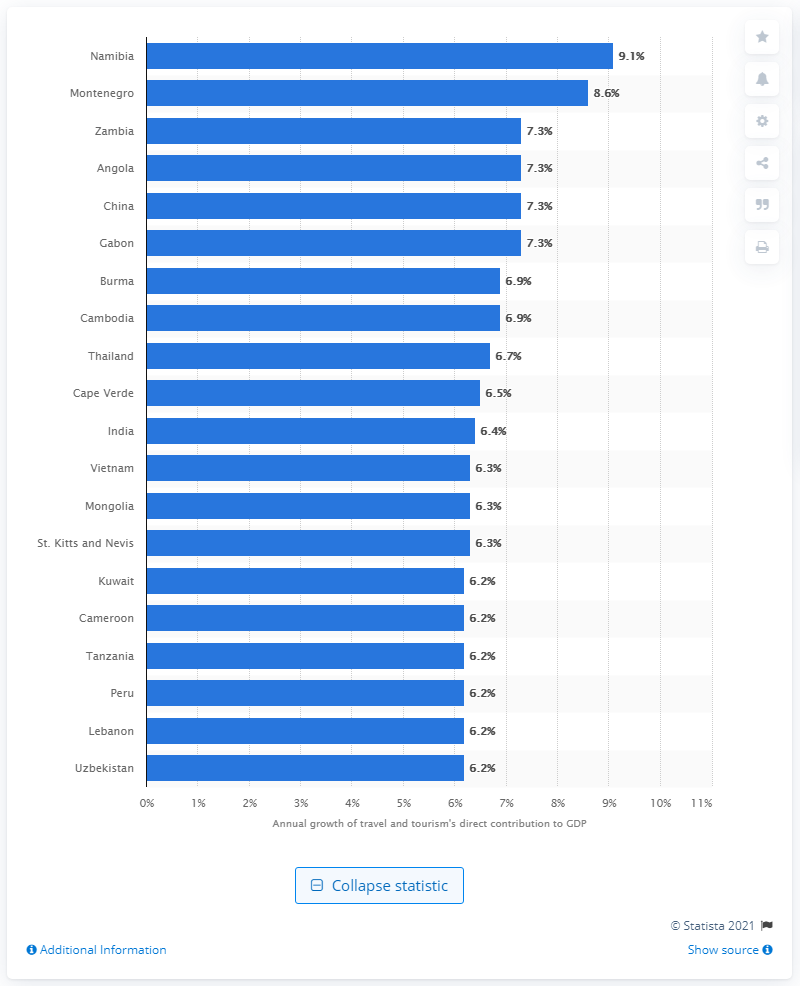Draw attention to some important aspects in this diagram. Zambia's annual growth rate is estimated to be 7.3%. Zambia is the third fastest emerging tourism destination in Africa. 